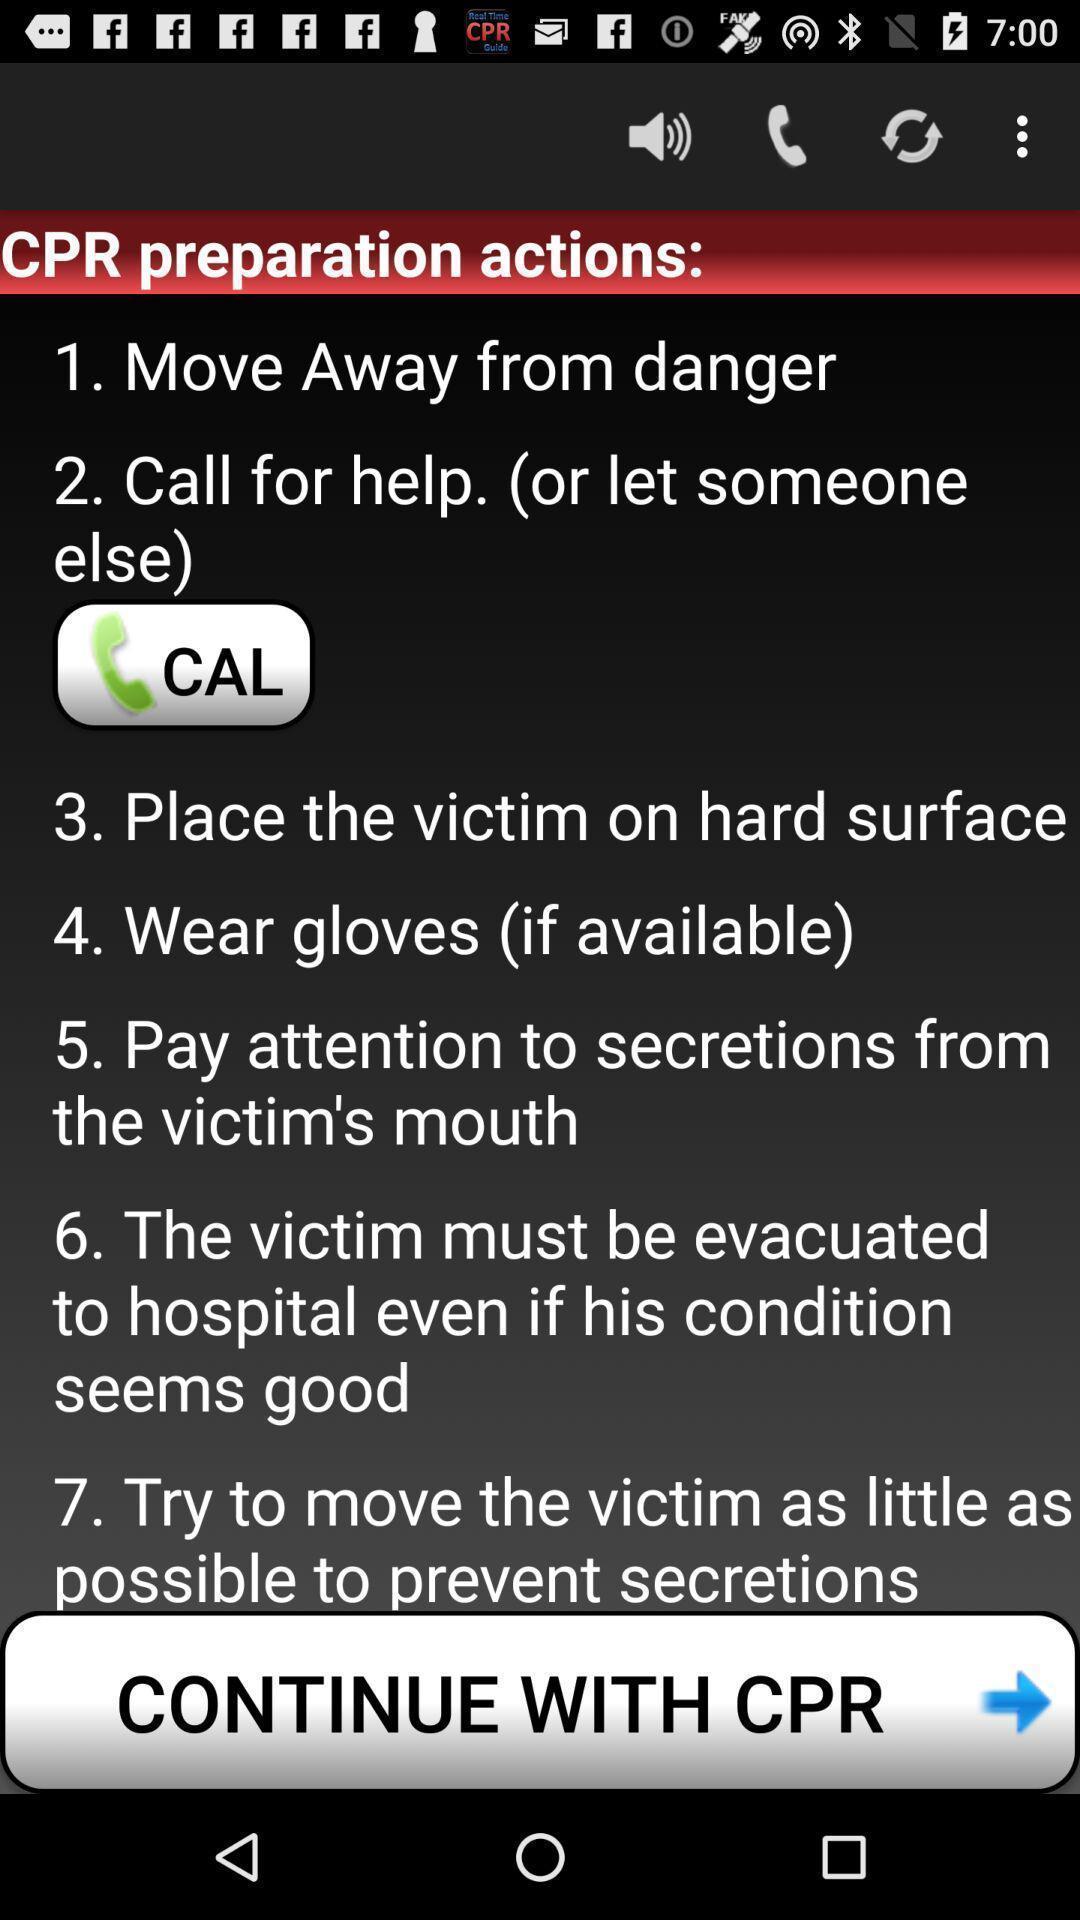Summarize the main components in this picture. Starting page of a security app. 